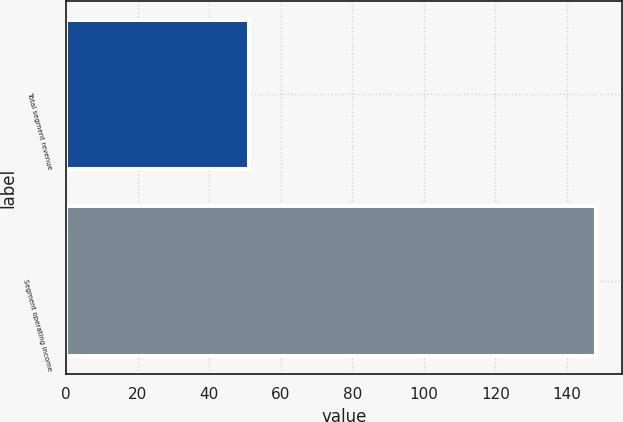<chart> <loc_0><loc_0><loc_500><loc_500><bar_chart><fcel>Total segment revenue<fcel>Segment operating income<nl><fcel>51<fcel>148<nl></chart> 